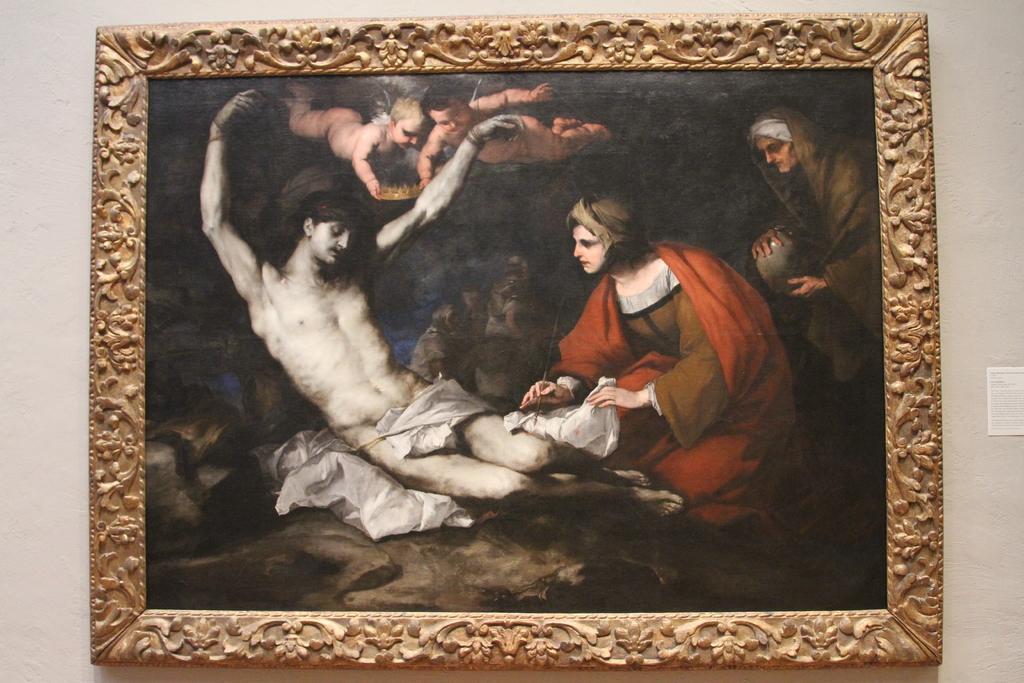Could you give a brief overview of what you see in this image? In this picture there is a frame on the wall and in the frame there is a painting image in which there are persons. 